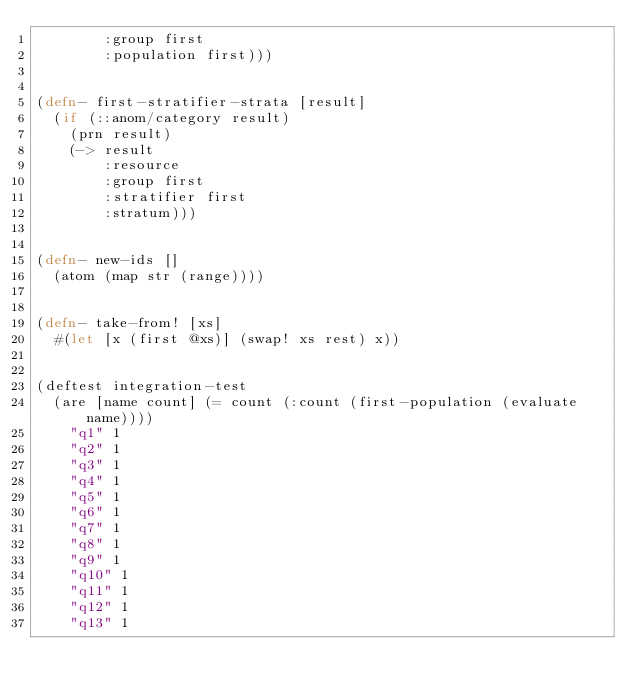Convert code to text. <code><loc_0><loc_0><loc_500><loc_500><_Clojure_>        :group first
        :population first)))


(defn- first-stratifier-strata [result]
  (if (::anom/category result)
    (prn result)
    (-> result
        :resource
        :group first
        :stratifier first
        :stratum)))


(defn- new-ids []
  (atom (map str (range))))


(defn- take-from! [xs]
  #(let [x (first @xs)] (swap! xs rest) x))


(deftest integration-test
  (are [name count] (= count (:count (first-population (evaluate name))))
    "q1" 1
    "q2" 1
    "q3" 1
    "q4" 1
    "q5" 1
    "q6" 1
    "q7" 1
    "q8" 1
    "q9" 1
    "q10" 1
    "q11" 1
    "q12" 1
    "q13" 1</code> 